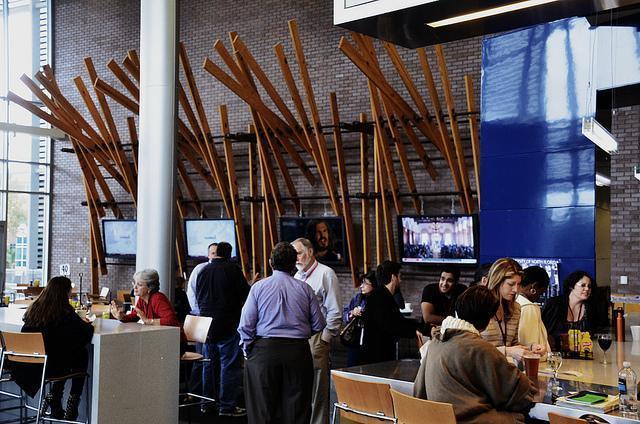How many bald men in this photo?
Give a very brief answer. 0. How many tvs are in the photo?
Give a very brief answer. 2. How many chairs can be seen?
Give a very brief answer. 3. How many dining tables are in the picture?
Give a very brief answer. 1. How many people can you see?
Give a very brief answer. 9. How many giraffes are there?
Give a very brief answer. 0. 